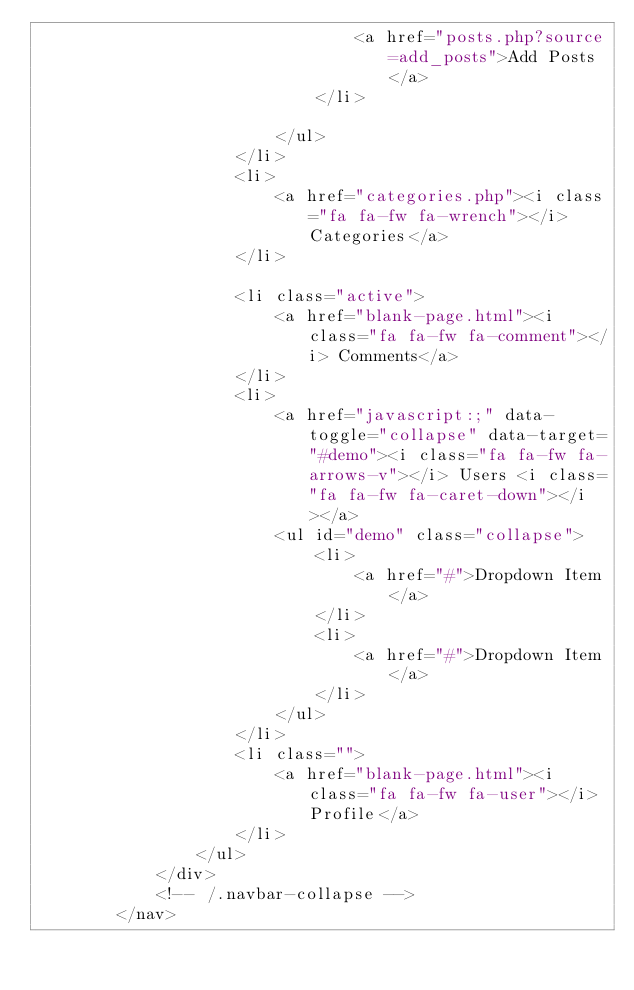<code> <loc_0><loc_0><loc_500><loc_500><_PHP_>                                <a href="posts.php?source=add_posts">Add Posts</a>
                            </li>
                           
                        </ul>
                    </li>
                    <li>
                        <a href="categories.php"><i class="fa fa-fw fa-wrench"></i> Categories</a>
                    </li>
                   
                    <li class="active">
                        <a href="blank-page.html"><i class="fa fa-fw fa-comment"></i> Comments</a>
                    </li>
                    <li>
                        <a href="javascript:;" data-toggle="collapse" data-target="#demo"><i class="fa fa-fw fa-arrows-v"></i> Users <i class="fa fa-fw fa-caret-down"></i></a>
                        <ul id="demo" class="collapse">
                            <li>
                                <a href="#">Dropdown Item</a>
                            </li>
                            <li>
                                <a href="#">Dropdown Item</a>
                            </li>
                        </ul>
                    </li>
                    <li class="">
                        <a href="blank-page.html"><i class="fa fa-fw fa-user"></i> Profile</a>
                    </li>
                </ul>
            </div>
            <!-- /.navbar-collapse -->
        </nav></code> 